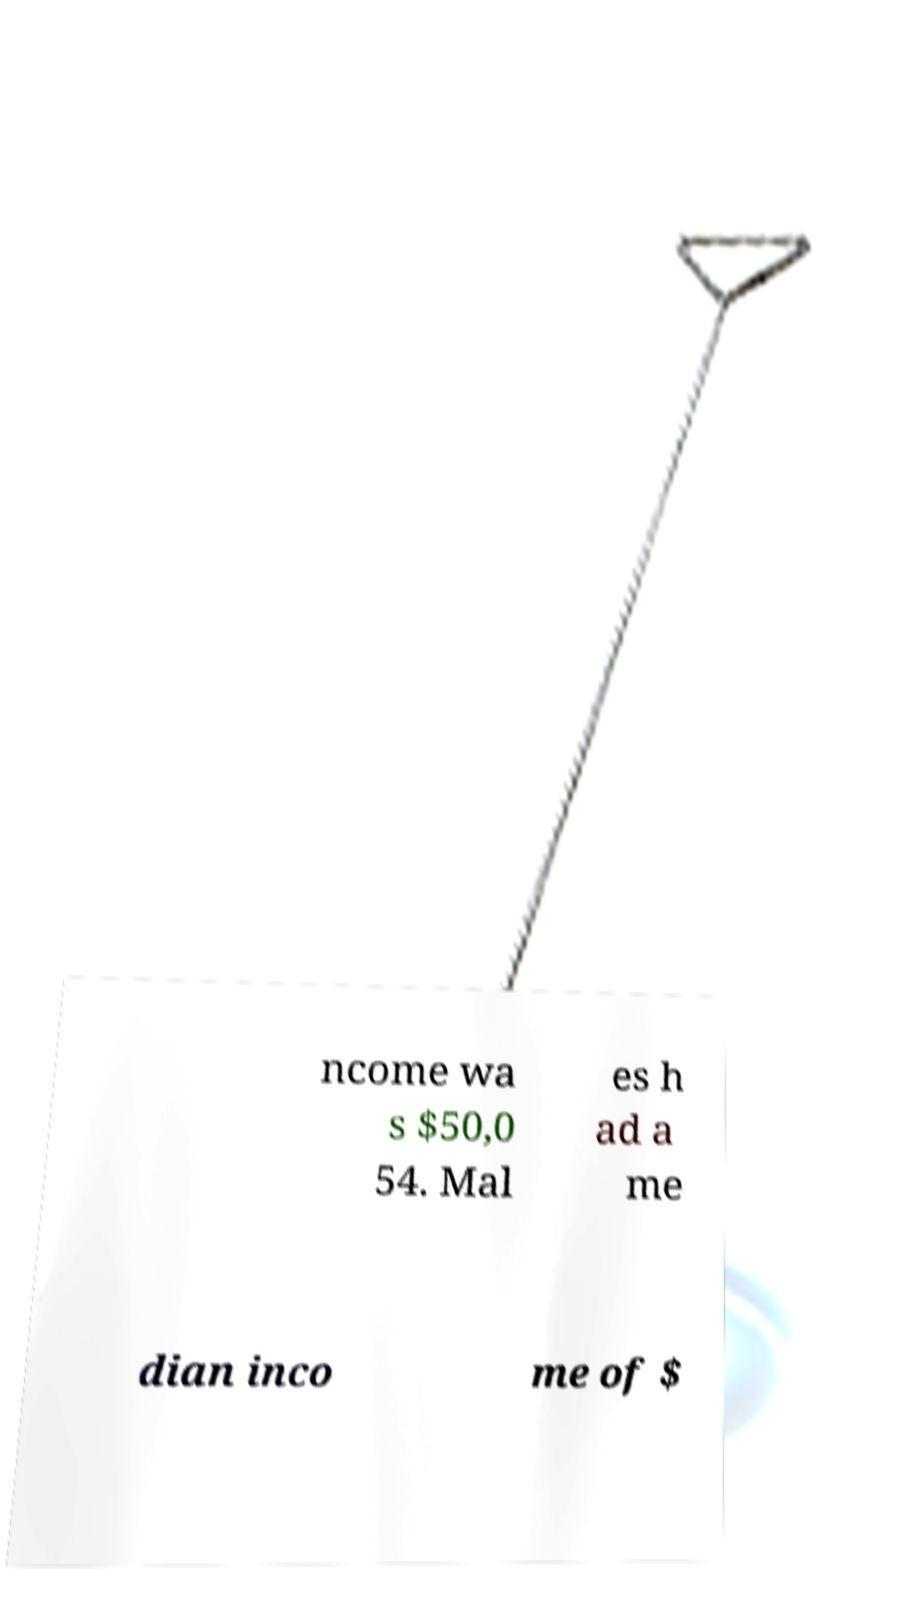I need the written content from this picture converted into text. Can you do that? ncome wa s $50,0 54. Mal es h ad a me dian inco me of $ 